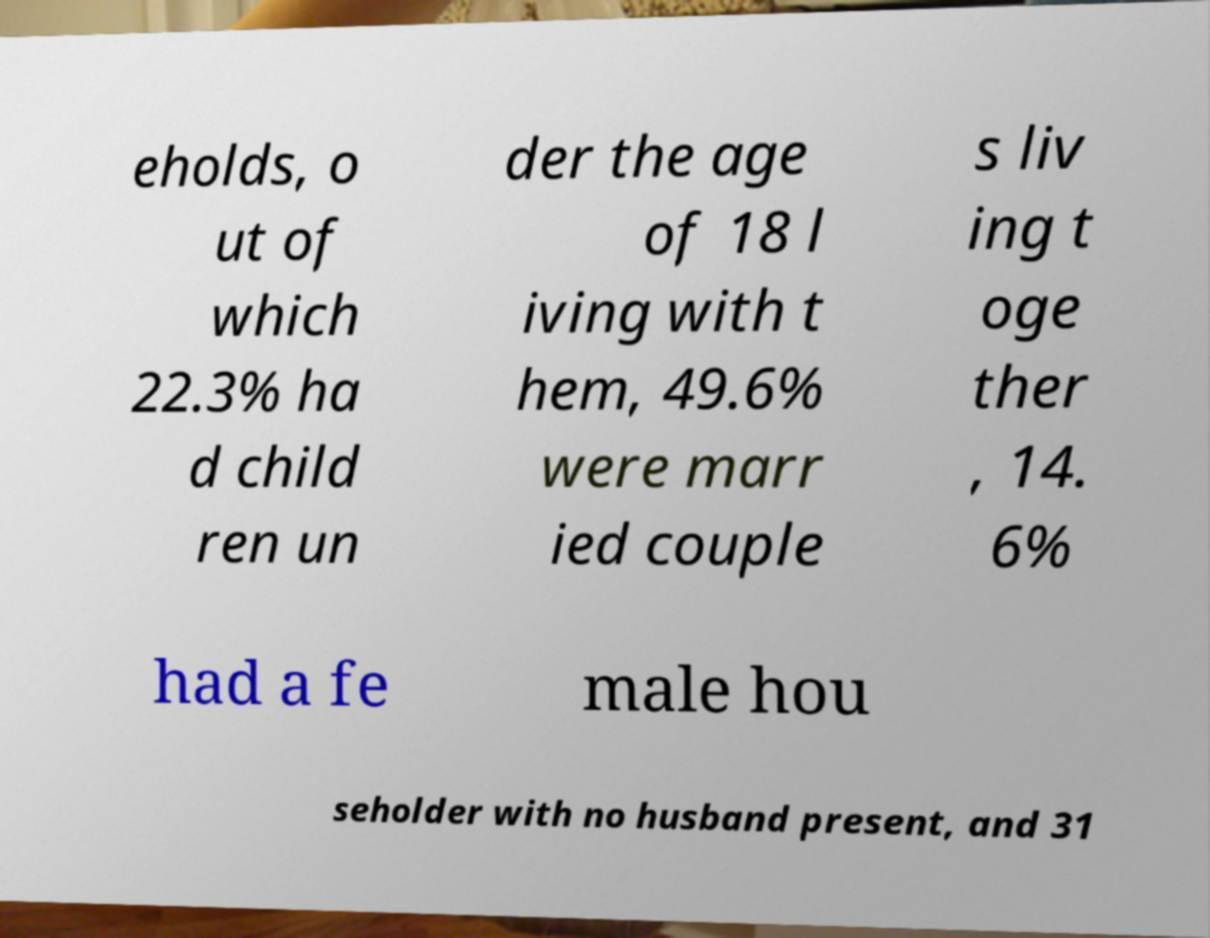What messages or text are displayed in this image? I need them in a readable, typed format. eholds, o ut of which 22.3% ha d child ren un der the age of 18 l iving with t hem, 49.6% were marr ied couple s liv ing t oge ther , 14. 6% had a fe male hou seholder with no husband present, and 31 